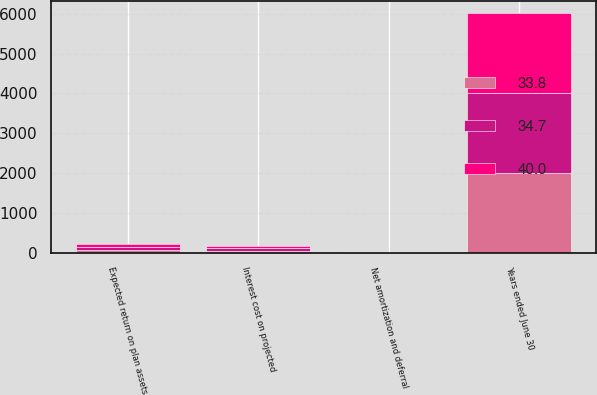Convert chart. <chart><loc_0><loc_0><loc_500><loc_500><stacked_bar_chart><ecel><fcel>Years ended June 30<fcel>Interest cost on projected<fcel>Expected return on plan assets<fcel>Net amortization and deferral<nl><fcel>40<fcel>2010<fcel>59.1<fcel>76.5<fcel>4.5<nl><fcel>34.7<fcel>2009<fcel>56.7<fcel>70.3<fcel>1.2<nl><fcel>33.8<fcel>2008<fcel>50.7<fcel>67.2<fcel>10.4<nl></chart> 